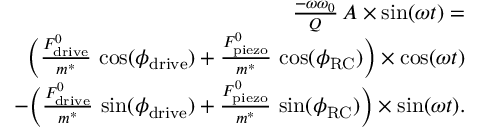<formula> <loc_0><loc_0><loc_500><loc_500>\begin{array} { r l r } & { \frac { - \omega \omega _ { 0 } } { Q } \, A \times \sin ( \omega t ) = } \\ & { \quad \left ( \frac { F _ { d r i v e } ^ { 0 } } { m ^ { * } } \, \cos ( \phi _ { d r i v e } ) + \frac { F _ { p i e z o } ^ { 0 } } { m ^ { * } } \, \cos ( \phi _ { R C } ) \right ) \times \cos ( \omega t ) } \\ & { \quad - \left ( \frac { F _ { d r i v e } ^ { 0 } } { m ^ { * } } \, \sin ( \phi _ { d r i v e } ) + \frac { F _ { p i e z o } ^ { 0 } } { m ^ { * } } \, \sin ( \phi _ { R C } ) \right ) \times \sin ( \omega t ) . } \end{array}</formula> 